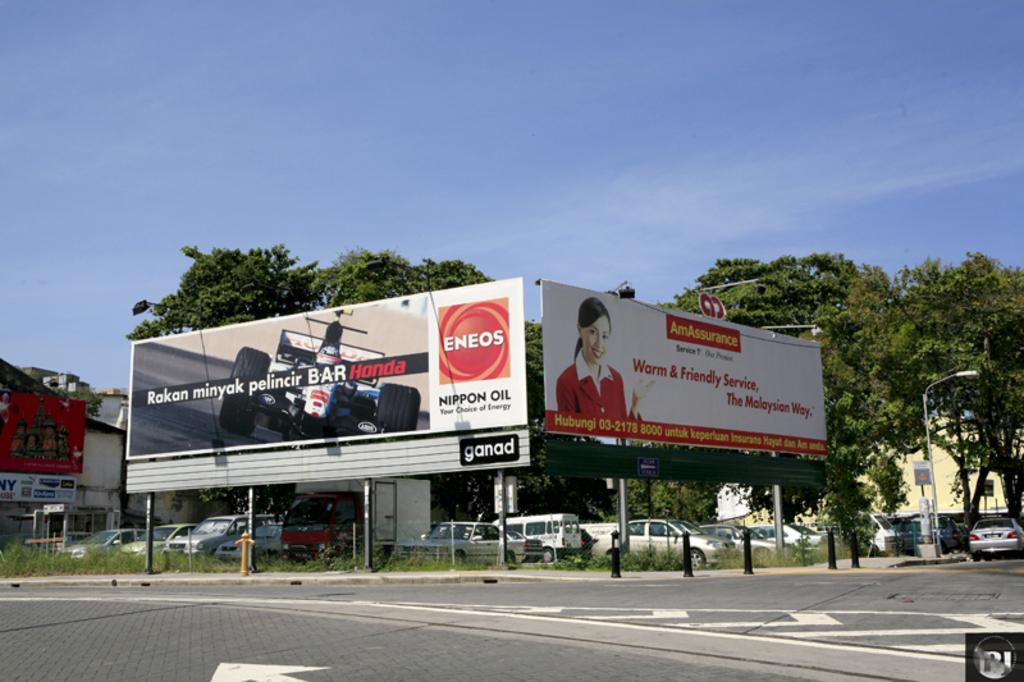<image>
Present a compact description of the photo's key features. Some large signs, one of which is advertising Nippon Oil. 